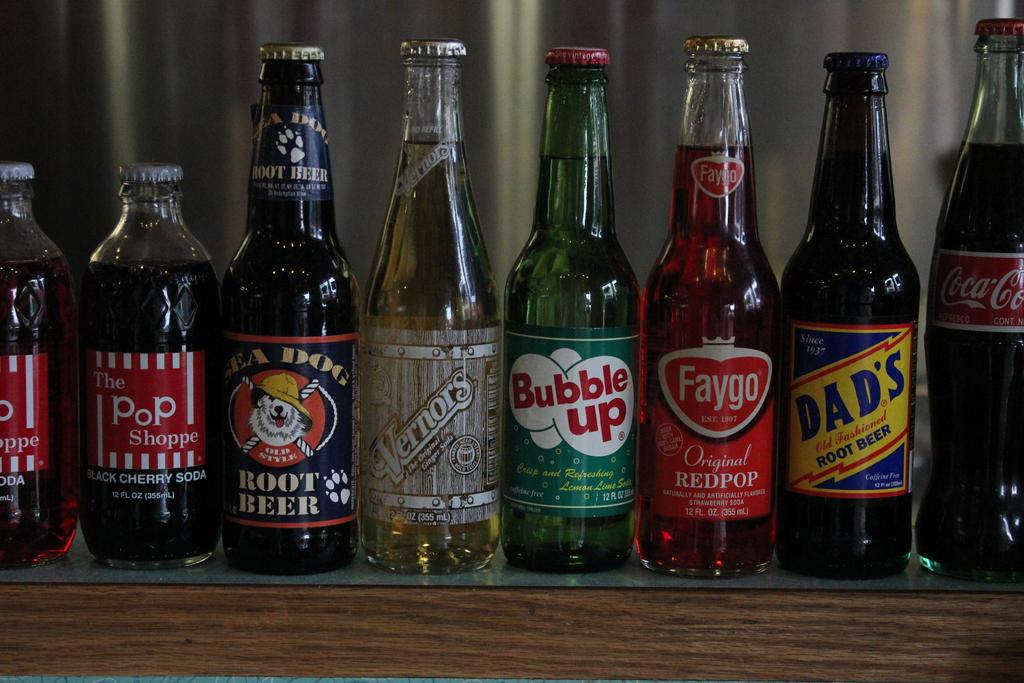What soda is in the bottle that says dad's?
Ensure brevity in your answer.  Root beer. 